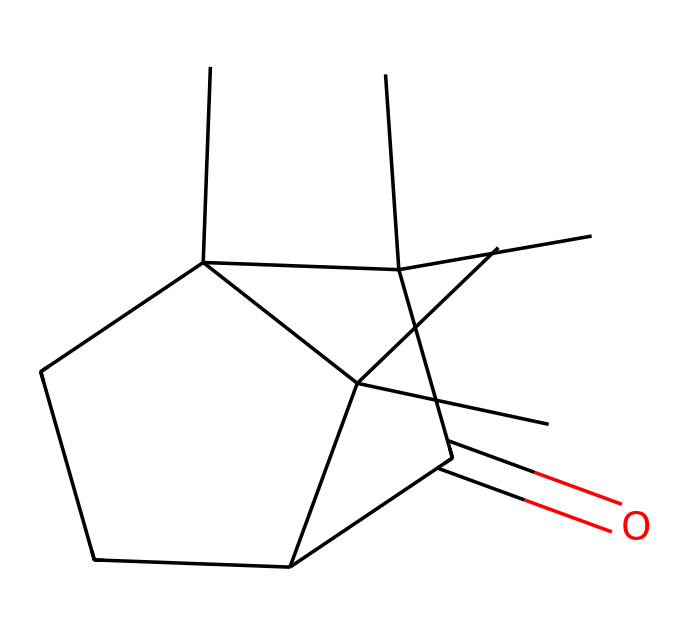What is the main functional group present in camphor? This chemical has a carbonyl group (C=O) that characterizes ketones, which is a functional group essential to its classification. In camphor, this functional group is part of the cyclic structure.
Answer: carbonyl How many carbon atoms are in camphor? Upon analyzing the SMILES structure, we count the carbon atoms explicitly. There are 15 carbon atoms present in the camphor structure.
Answer: 15 How many rings are in the structure of camphor? The structure shows the presence of two interconnected rings. By counting, we can identify the rings that form the bicyclic structure.
Answer: 2 What type of compound is camphor classified as? Camphor's structure includes a carbonyl group within a hydrophobic carbon chain, which categorizes it as a ketone. This classification is due to the presence of the ketone functional group in its structure.
Answer: ketone What is the total number of hydrogen atoms in camphor? By examining the SMILES notation and taking into account the tetravalency of carbon along with the hydrogen bonding situation, we find that there are 26 hydrogen atoms in camphor.
Answer: 26 Is camphor a natural or synthetic compound? Camphor is derived from the wood of camphor trees, confirming its status as a natural compound. While it can also be synthesized, its origin is primarily natural.
Answer: natural 